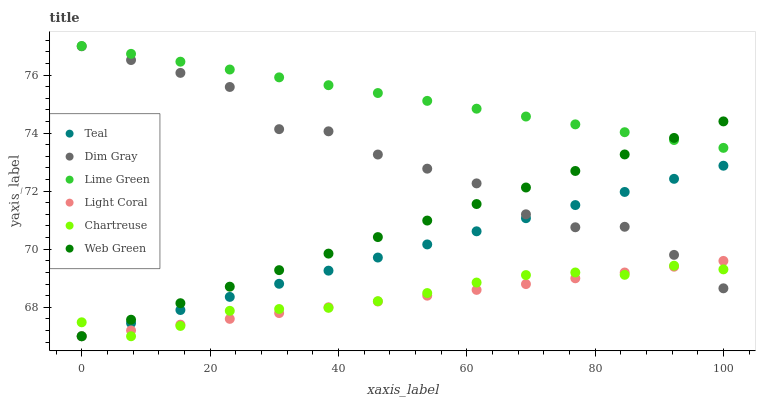Does Light Coral have the minimum area under the curve?
Answer yes or no. Yes. Does Lime Green have the maximum area under the curve?
Answer yes or no. Yes. Does Web Green have the minimum area under the curve?
Answer yes or no. No. Does Web Green have the maximum area under the curve?
Answer yes or no. No. Is Lime Green the smoothest?
Answer yes or no. Yes. Is Dim Gray the roughest?
Answer yes or no. Yes. Is Web Green the smoothest?
Answer yes or no. No. Is Web Green the roughest?
Answer yes or no. No. Does Web Green have the lowest value?
Answer yes or no. Yes. Does Lime Green have the lowest value?
Answer yes or no. No. Does Lime Green have the highest value?
Answer yes or no. Yes. Does Web Green have the highest value?
Answer yes or no. No. Is Dim Gray less than Lime Green?
Answer yes or no. Yes. Is Lime Green greater than Teal?
Answer yes or no. Yes. Does Light Coral intersect Dim Gray?
Answer yes or no. Yes. Is Light Coral less than Dim Gray?
Answer yes or no. No. Is Light Coral greater than Dim Gray?
Answer yes or no. No. Does Dim Gray intersect Lime Green?
Answer yes or no. No. 